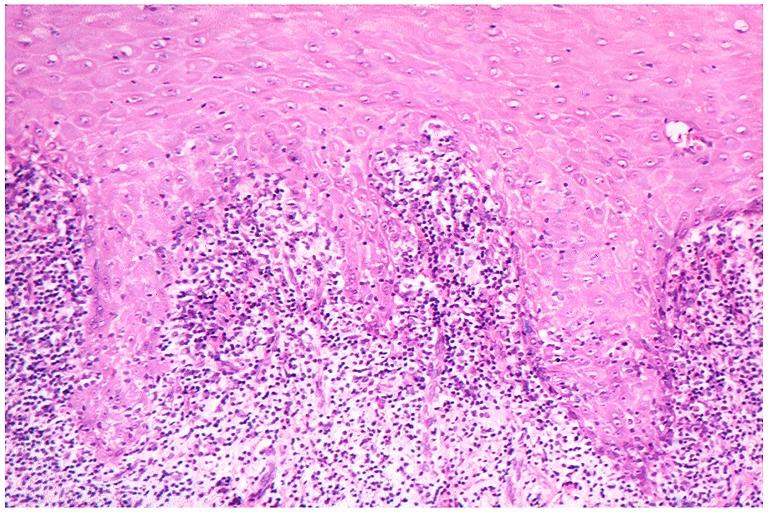s oral present?
Answer the question using a single word or phrase. Yes 